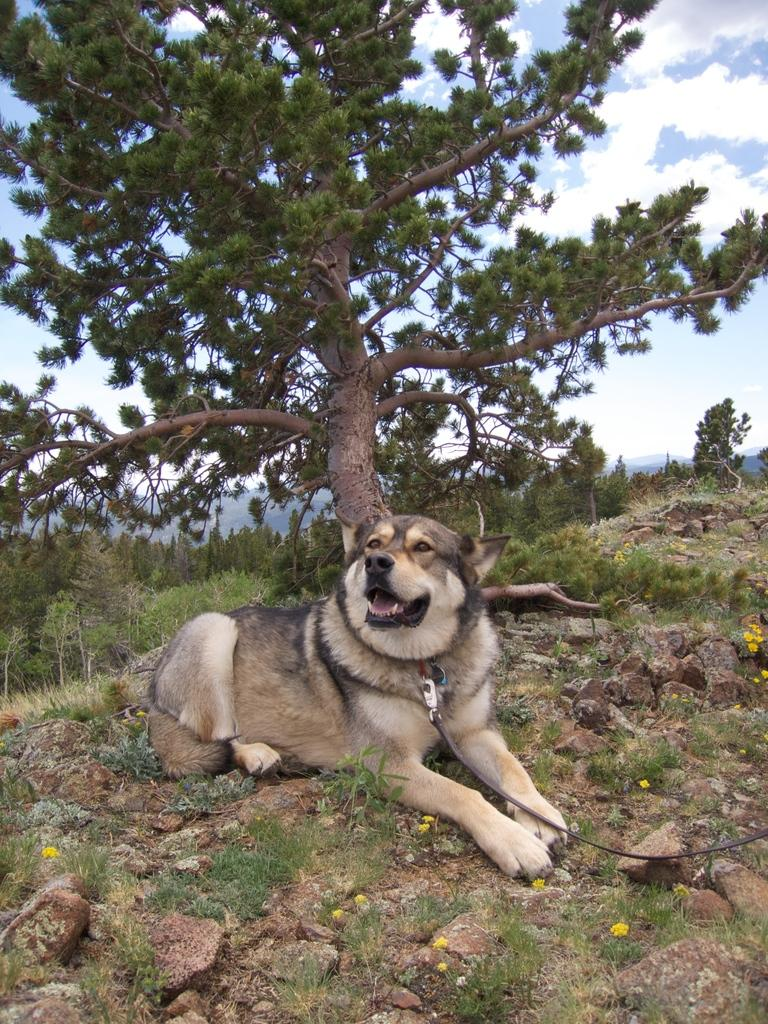What type of animal is in the image? There is a dog in the image. What is the dog wearing? The dog is wearing a belt. What type of terrain is visible in the image? There is grass, stones, and trees in the image. What is visible in the background of the image? The sky is visible in the background of the image, and there are clouds in the sky. What riddle does the dog solve in the image? There is no riddle present in the image, nor is the dog solving any riddles. Who is in control of the dog in the image? The image does not depict anyone controlling the dog, so it is not possible to determine who is in control. 